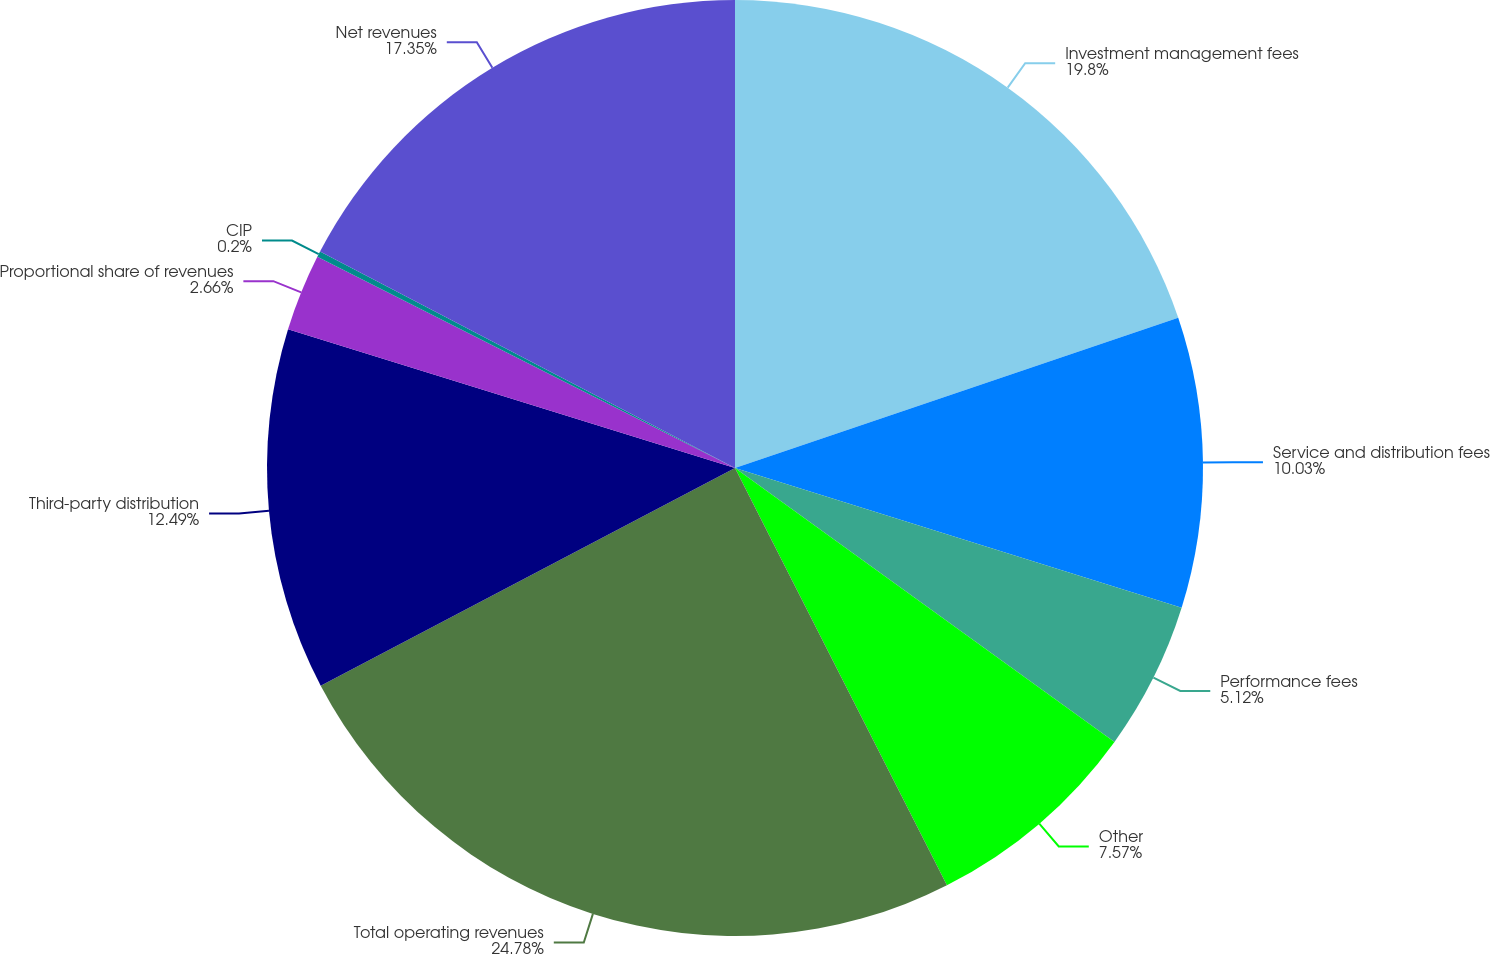Convert chart to OTSL. <chart><loc_0><loc_0><loc_500><loc_500><pie_chart><fcel>Investment management fees<fcel>Service and distribution fees<fcel>Performance fees<fcel>Other<fcel>Total operating revenues<fcel>Third-party distribution<fcel>Proportional share of revenues<fcel>CIP<fcel>Net revenues<nl><fcel>19.8%<fcel>10.03%<fcel>5.12%<fcel>7.57%<fcel>24.78%<fcel>12.49%<fcel>2.66%<fcel>0.2%<fcel>17.35%<nl></chart> 